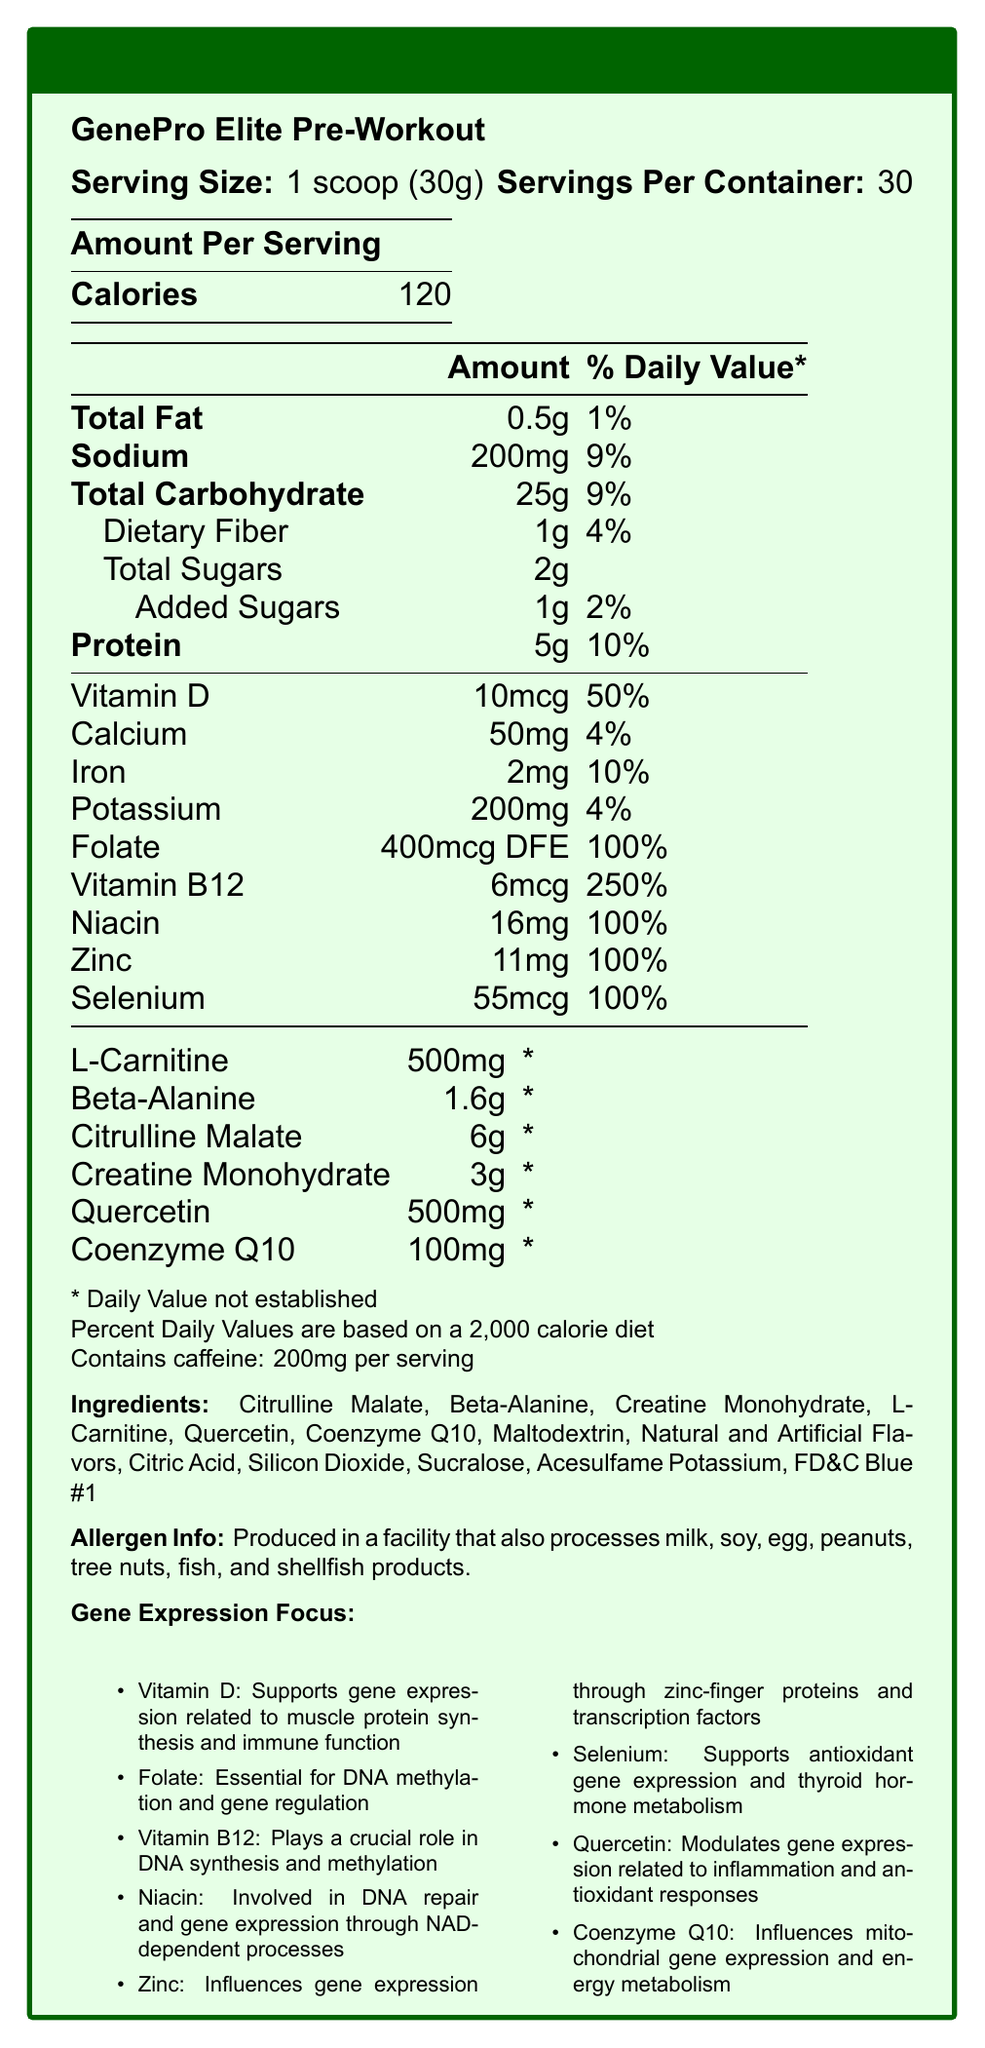what is the serving size of GenePro Elite Pre-Workout? The serving size is specified as "1 scoop (30g)" in the document under the product name.
Answer: 1 scoop (30g) how many calories are in one serving of GenePro Elite Pre-Workout? The document lists the amount of calories per serving as 120.
Answer: 120 calories what is the amount of Vitamin B12 per serving, and what is its percent daily value? The document shows that Vitamin B12 content is 6mcg with a percent daily value of 250%.
Answer: 6mcg, 250% how much creatine monohydrate is included per serving? The document specifies that each serving contains 3g of creatine monohydrate.
Answer: 3g which micronutrient supports gene expression related to muscle protein synthesis and immune function? The document's "Gene Expression Focus" section mentions that Vitamin D supports gene expression related to muscle protein synthesis and immune function.
Answer: Vitamin D which micronutrient is essential for DNA methylation and gene regulation? According to the "Gene Expression Focus" section, Folate is essential for DNA methylation and gene regulation.
Answer: Folate how many servings are there in one container of GenePro Elite Pre-Workout? The "servings per container" value in the document is 30.
Answer: 30 servings what is the percent daily value of niacin per serving? The document lists niacin with a percent daily value of 100%.
Answer: 100% how much sodium is in a single serving? A. 150mg B. 200mg C. 250mg The document specifies that a single serving contains 200mg of sodium.
Answer: B. 200mg what is the amount of quercetin per serving? A. 100mg B. 200mg C. 500mg D. 1000mg The document lists the amount of quercetin per serving as 500mg.
Answer: C. 500mg is there any caffeine in GenePro Elite Pre-Workout? The additional info in the document indicates that there is 200mg of caffeine per serving.
Answer: Yes does the product contain any potential allergens? The allergen info section states that it is produced in a facility that also processes milk, soy, egg, peanuts, tree nuts, fish, and shellfish products.
Answer: Yes what are the main functions of quercetin according to the gene expression focus? The gene expression focus section specifies these roles of quercetin.
Answer: Modulates gene expression related to inflammation and antioxidant responses what is the total amount of added sugars per serving and its percent daily value? The document indicates that the total amount of added sugars per serving is 1g with a percent daily value of 2%.
Answer: 1g, 2% what is the primary message of the document? The document details the nutritional content including vitamins and minerals, describes the specific micronutrients that influence gene expression, and lists the ingredients and potential allergens.
Answer: The document provides the nutritional facts and ingredients of GenePro Elite Pre-Workout, highlighting its micronutrients influencing gene expression and key ingredients that support athletic performance. does the document provide the exact caffeine source? The document only mentions the caffeine content per serving, but it does not specify the source of the caffeine.
Answer: Cannot be determined 